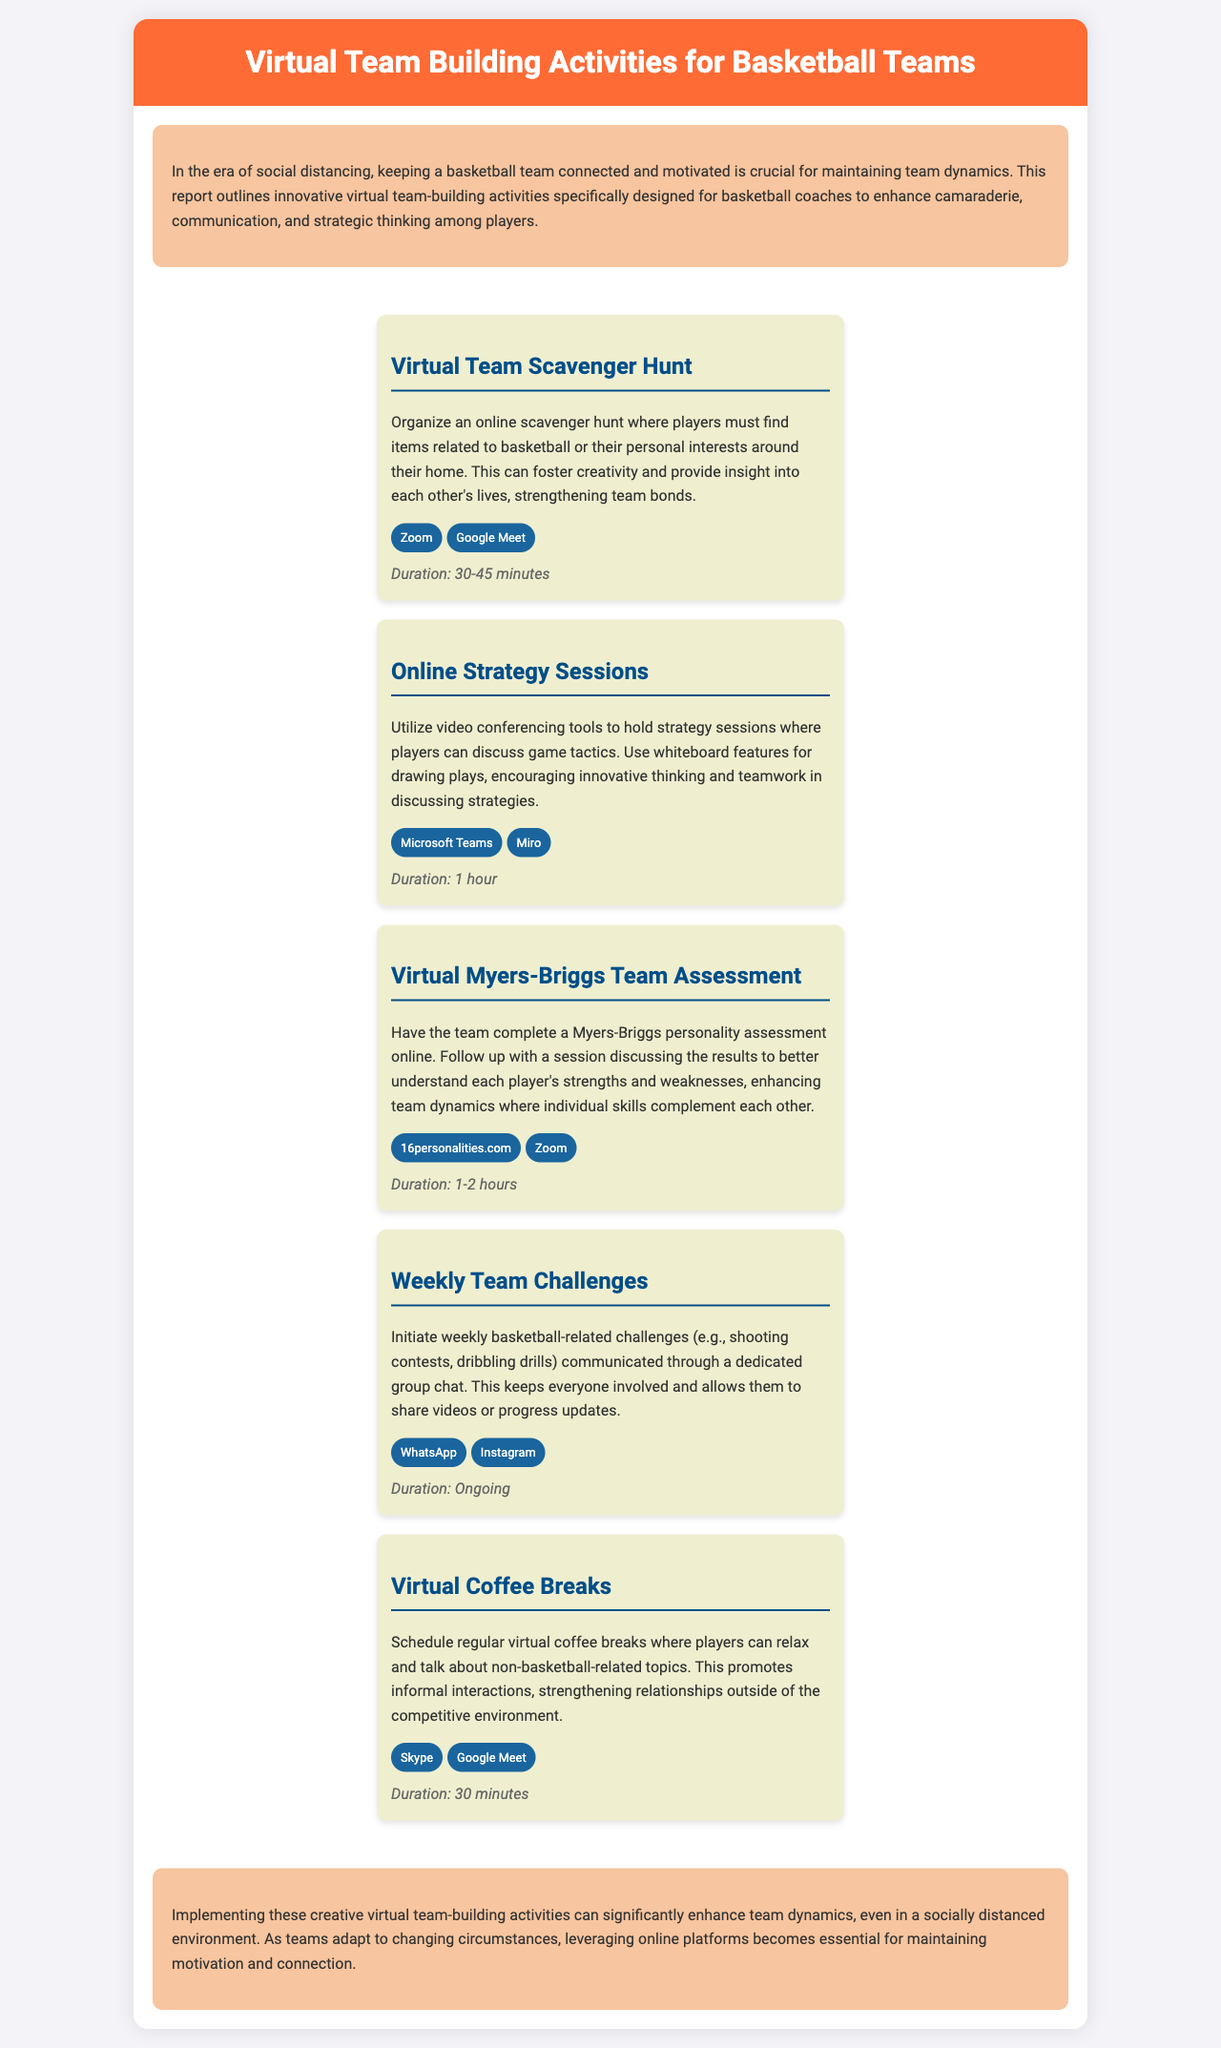what is the title of the report? The title is presented at the top of the document.
Answer: Virtual Team Building Activities for Basketball Teams how many virtual team-building activities are listed? The number of activities can be counted in the activities section of the document.
Answer: Five what is the duration of the Virtual Team Scavenger Hunt? The duration is specified below the activity description in the document.
Answer: 30-45 minutes which online platform is suggested for the Online Strategy Sessions? The platform is mentioned within the context of the activity.
Answer: Microsoft Teams what is a benefit of conducting the Virtual Myers-Briggs Team Assessment? The benefit is highlighted in the description of that activity in the document.
Answer: Enhance team dynamics which platforms are suggested for the Weekly Team Challenges? The platforms are listed in the activity section for that challenge.
Answer: WhatsApp, Instagram what is the purpose of the Virtual Coffee Breaks? The purpose is described at the beginning of the activity's explanation.
Answer: Strengthening relationships how long should the Online Strategy Sessions last? The duration is clearly stated in the document beneath the activity description.
Answer: 1 hour what color is used for the header in the document? The color is mentioned in the style settings and can be visually identified.
Answer: Orange 